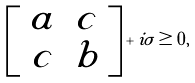Convert formula to latex. <formula><loc_0><loc_0><loc_500><loc_500>\left [ \begin{array} { c c } a & c \\ c & b \end{array} \right ] + i \sigma \geq 0 ,</formula> 